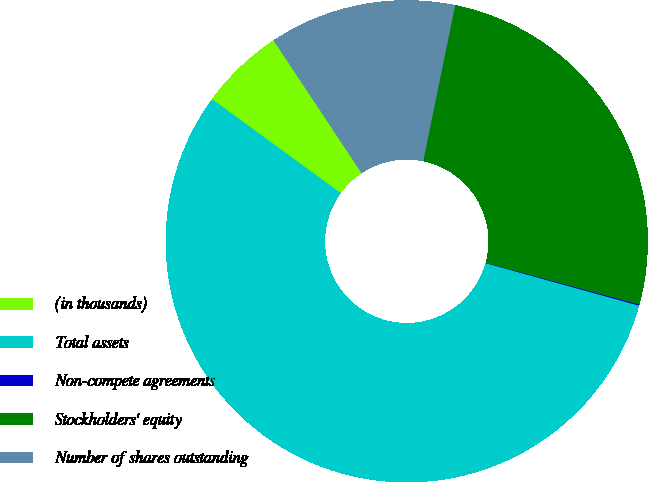Convert chart to OTSL. <chart><loc_0><loc_0><loc_500><loc_500><pie_chart><fcel>(in thousands)<fcel>Total assets<fcel>Non-compete agreements<fcel>Stockholders' equity<fcel>Number of shares outstanding<nl><fcel>5.65%<fcel>55.74%<fcel>0.08%<fcel>26.01%<fcel>12.53%<nl></chart> 